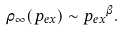Convert formula to latex. <formula><loc_0><loc_0><loc_500><loc_500>\rho _ { \infty } ( p _ { e x } ) \sim { p _ { e x } } ^ { \beta } .</formula> 